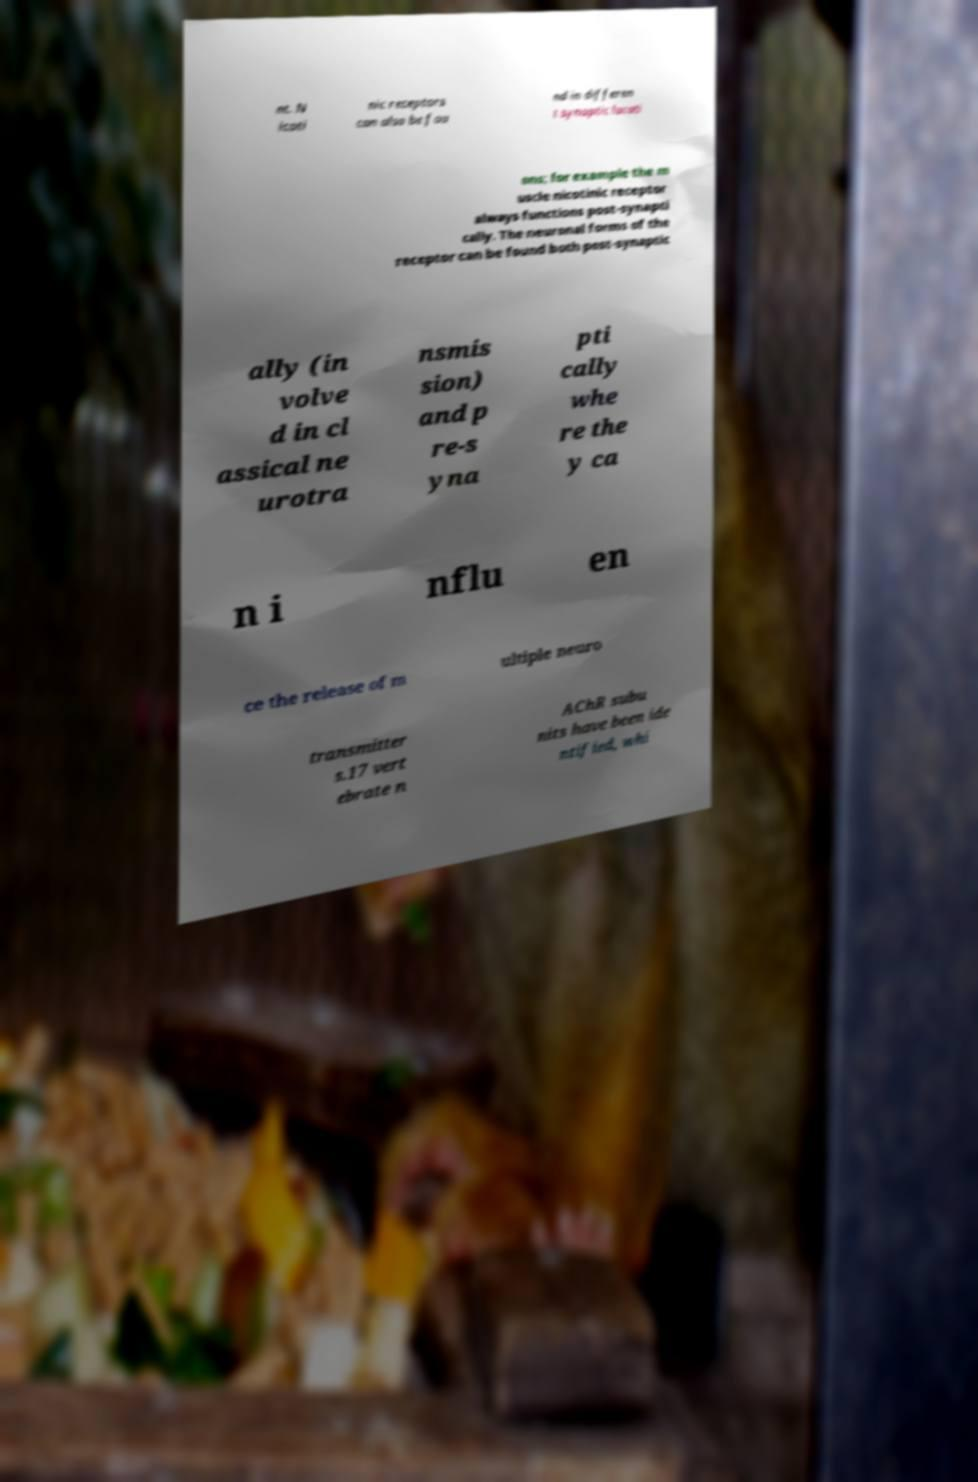Could you assist in decoding the text presented in this image and type it out clearly? nt. N icoti nic receptors can also be fou nd in differen t synaptic locati ons; for example the m uscle nicotinic receptor always functions post-synapti cally. The neuronal forms of the receptor can be found both post-synaptic ally (in volve d in cl assical ne urotra nsmis sion) and p re-s yna pti cally whe re the y ca n i nflu en ce the release of m ultiple neuro transmitter s.17 vert ebrate n AChR subu nits have been ide ntified, whi 